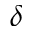Convert formula to latex. <formula><loc_0><loc_0><loc_500><loc_500>\delta</formula> 